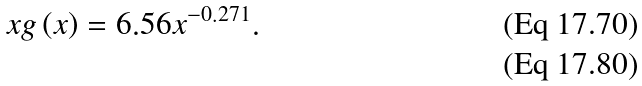Convert formula to latex. <formula><loc_0><loc_0><loc_500><loc_500>x g \left ( x \right ) = 6 . 5 6 x ^ { - 0 . 2 7 1 } . \\</formula> 